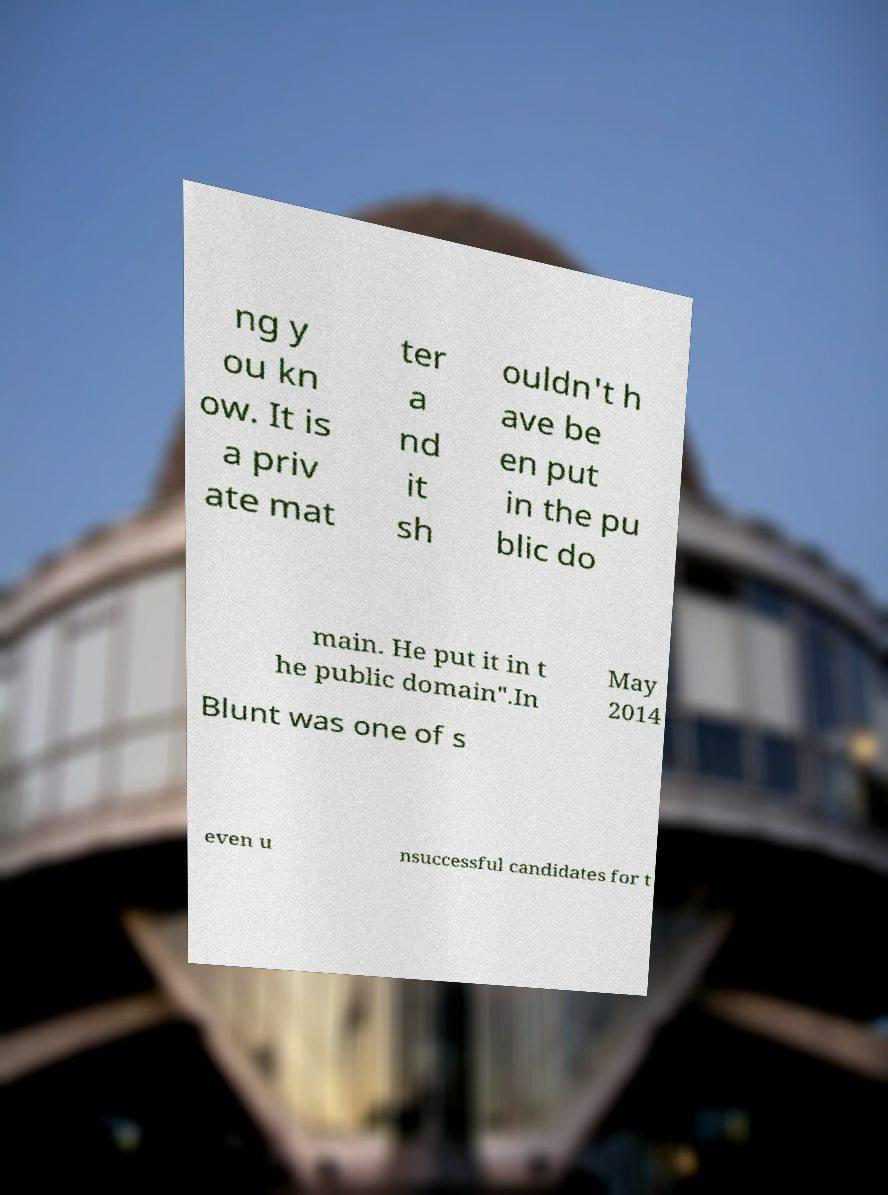Please identify and transcribe the text found in this image. ng y ou kn ow. It is a priv ate mat ter a nd it sh ouldn't h ave be en put in the pu blic do main. He put it in t he public domain".In May 2014 Blunt was one of s even u nsuccessful candidates for t 